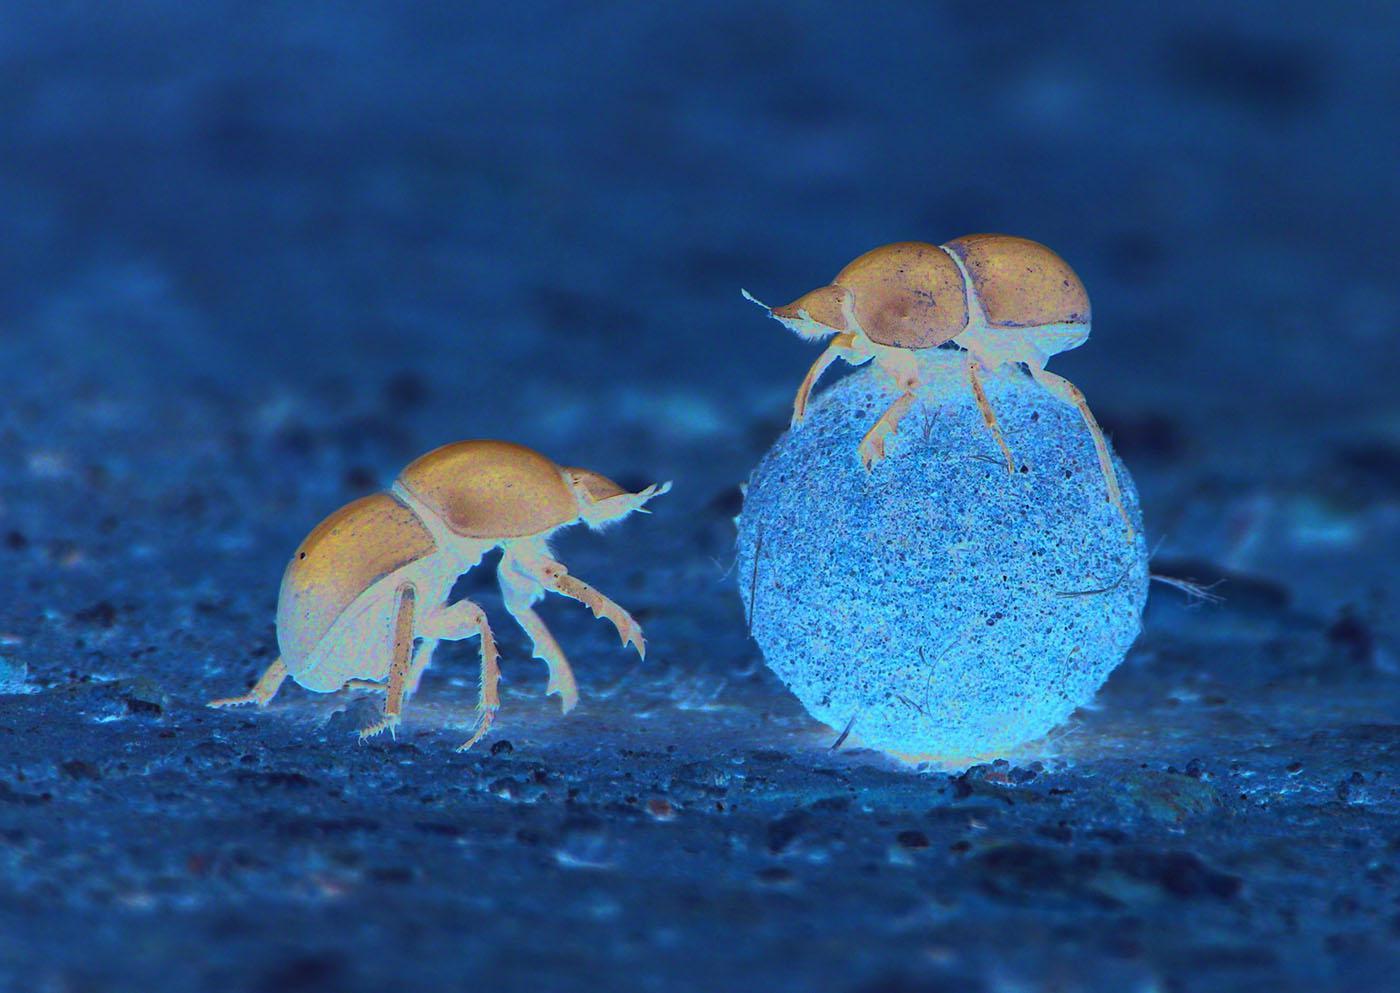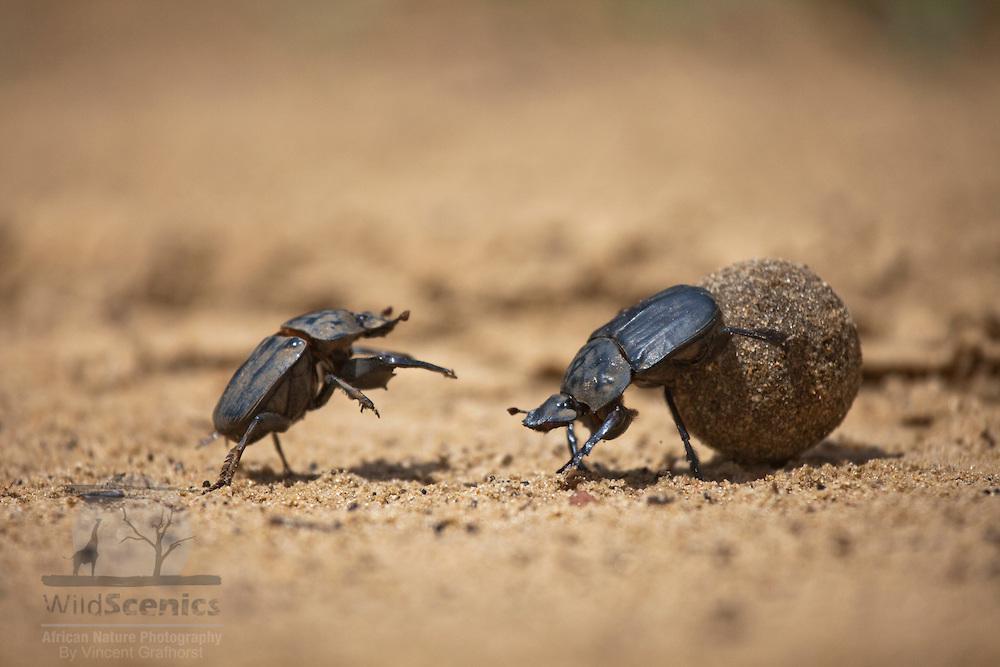The first image is the image on the left, the second image is the image on the right. Considering the images on both sides, is "There are two beatles in total." valid? Answer yes or no. No. 